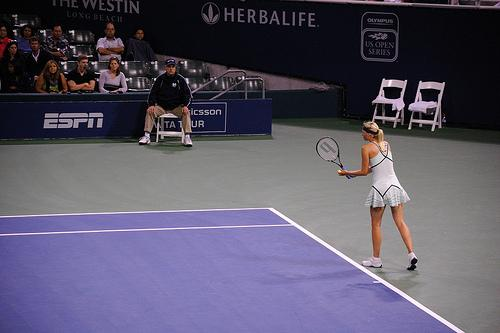List the clothing and equipment of the woman playing tennis. The woman is wearing a white dress, white tennis shoes, and a black hairband. She is holding a tennis racket and a yellow tennis ball. What is the primary action happening in this picture? A woman is playing a tennis game, about to serve the ball. Can you identify the number of tennis rackets visible in the image? Provide the count. There are two tennis rackets visible in the image. Mention some notable accessories of people in the image. A black headband, a tattoo on the upper thigh, and a dark blue ball cap. Some people are watching the tennis game in the image. Can you describe them? There is a man watching the game with folded arms, a woman watching the game, and a match official with hands holding the knees. What are some objects you see in the picture that are not directly related to the game of tennis? A white towel, a dark blue ball cap, and audience seating. What kind of seating arrangements are there in the image? There are white wooden folding chairs, a pair of white empty seats, and rows of other seats for the spectators. Can you tell if there's a particular brand visible in the image? Yes, there is a white colored ESPN logo visible. Can you see something on the inner wall of the arena? If yes, what is it? There is branding on the inner wall of the arena. What is the color of the ground of the tennis court? The ground of the tennis court is blue. 